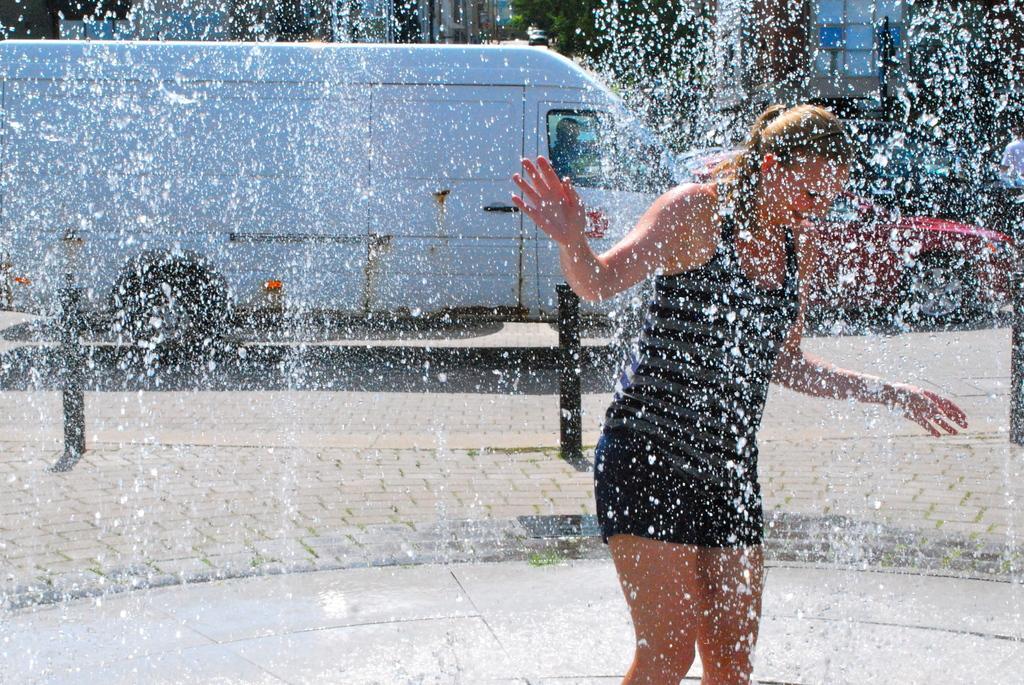Please provide a concise description of this image. There is a woman playing in the fountain water behind the woman there is a truck and a car moving on the road. 